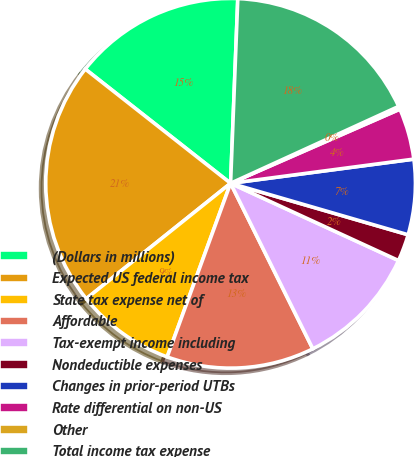Convert chart to OTSL. <chart><loc_0><loc_0><loc_500><loc_500><pie_chart><fcel>(Dollars in millions)<fcel>Expected US federal income tax<fcel>State tax expense net of<fcel>Affordable<fcel>Tax-exempt income including<fcel>Nondeductible expenses<fcel>Changes in prior-period UTBs<fcel>Rate differential on non-US<fcel>Other<fcel>Total income tax expense<nl><fcel>15.02%<fcel>21.34%<fcel>8.69%<fcel>12.91%<fcel>10.8%<fcel>2.37%<fcel>6.58%<fcel>4.48%<fcel>0.26%<fcel>17.55%<nl></chart> 